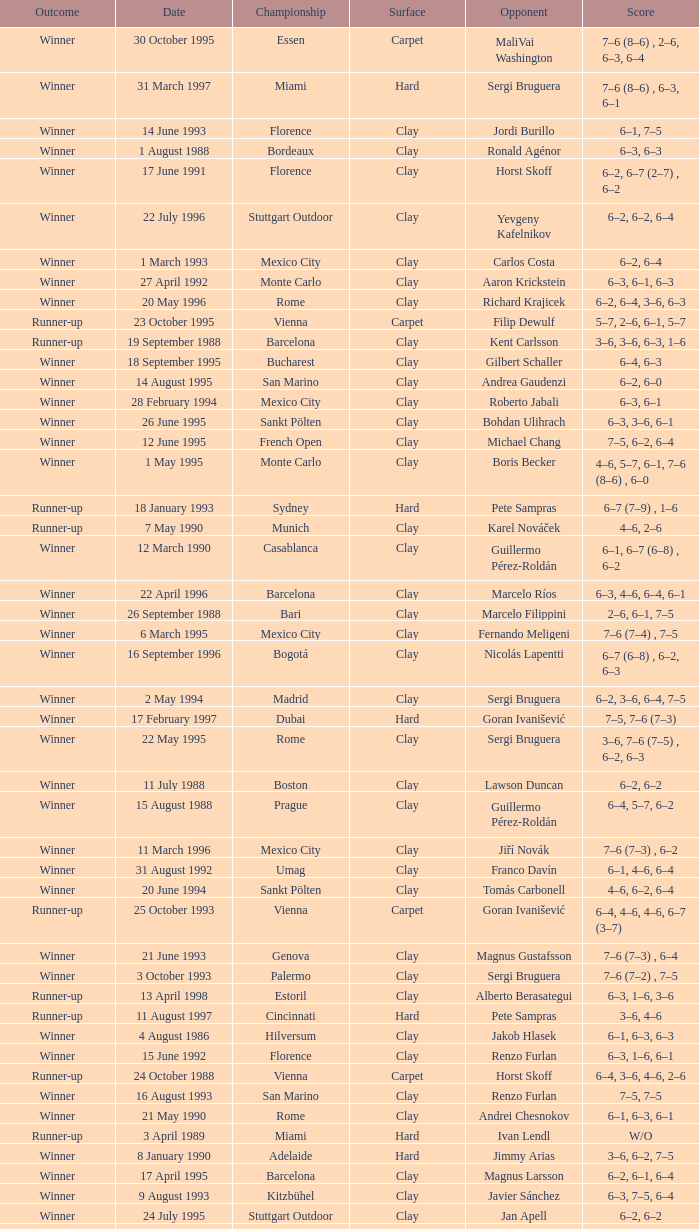Give me the full table as a dictionary. {'header': ['Outcome', 'Date', 'Championship', 'Surface', 'Opponent', 'Score'], 'rows': [['Winner', '30 October 1995', 'Essen', 'Carpet', 'MaliVai Washington', '7–6 (8–6) , 2–6, 6–3, 6–4'], ['Winner', '31 March 1997', 'Miami', 'Hard', 'Sergi Bruguera', '7–6 (8–6) , 6–3, 6–1'], ['Winner', '14 June 1993', 'Florence', 'Clay', 'Jordi Burillo', '6–1, 7–5'], ['Winner', '1 August 1988', 'Bordeaux', 'Clay', 'Ronald Agénor', '6–3, 6–3'], ['Winner', '17 June 1991', 'Florence', 'Clay', 'Horst Skoff', '6–2, 6–7 (2–7) , 6–2'], ['Winner', '22 July 1996', 'Stuttgart Outdoor', 'Clay', 'Yevgeny Kafelnikov', '6–2, 6–2, 6–4'], ['Winner', '1 March 1993', 'Mexico City', 'Clay', 'Carlos Costa', '6–2, 6–4'], ['Winner', '27 April 1992', 'Monte Carlo', 'Clay', 'Aaron Krickstein', '6–3, 6–1, 6–3'], ['Winner', '20 May 1996', 'Rome', 'Clay', 'Richard Krajicek', '6–2, 6–4, 3–6, 6–3'], ['Runner-up', '23 October 1995', 'Vienna', 'Carpet', 'Filip Dewulf', '5–7, 2–6, 6–1, 5–7'], ['Runner-up', '19 September 1988', 'Barcelona', 'Clay', 'Kent Carlsson', '3–6, 3–6, 6–3, 1–6'], ['Winner', '18 September 1995', 'Bucharest', 'Clay', 'Gilbert Schaller', '6–4, 6–3'], ['Winner', '14 August 1995', 'San Marino', 'Clay', 'Andrea Gaudenzi', '6–2, 6–0'], ['Winner', '28 February 1994', 'Mexico City', 'Clay', 'Roberto Jabali', '6–3, 6–1'], ['Winner', '26 June 1995', 'Sankt Pölten', 'Clay', 'Bohdan Ulihrach', '6–3, 3–6, 6–1'], ['Winner', '12 June 1995', 'French Open', 'Clay', 'Michael Chang', '7–5, 6–2, 6–4'], ['Winner', '1 May 1995', 'Monte Carlo', 'Clay', 'Boris Becker', '4–6, 5–7, 6–1, 7–6 (8–6) , 6–0'], ['Runner-up', '18 January 1993', 'Sydney', 'Hard', 'Pete Sampras', '6–7 (7–9) , 1–6'], ['Runner-up', '7 May 1990', 'Munich', 'Clay', 'Karel Nováček', '4–6, 2–6'], ['Winner', '12 March 1990', 'Casablanca', 'Clay', 'Guillermo Pérez-Roldán', '6–1, 6–7 (6–8) , 6–2'], ['Winner', '22 April 1996', 'Barcelona', 'Clay', 'Marcelo Ríos', '6–3, 4–6, 6–4, 6–1'], ['Winner', '26 September 1988', 'Bari', 'Clay', 'Marcelo Filippini', '2–6, 6–1, 7–5'], ['Winner', '6 March 1995', 'Mexico City', 'Clay', 'Fernando Meligeni', '7–6 (7–4) , 7–5'], ['Winner', '16 September 1996', 'Bogotá', 'Clay', 'Nicolás Lapentti', '6–7 (6–8) , 6–2, 6–3'], ['Winner', '2 May 1994', 'Madrid', 'Clay', 'Sergi Bruguera', '6–2, 3–6, 6–4, 7–5'], ['Winner', '17 February 1997', 'Dubai', 'Hard', 'Goran Ivanišević', '7–5, 7–6 (7–3)'], ['Winner', '22 May 1995', 'Rome', 'Clay', 'Sergi Bruguera', '3–6, 7–6 (7–5) , 6–2, 6–3'], ['Winner', '11 July 1988', 'Boston', 'Clay', 'Lawson Duncan', '6–2, 6–2'], ['Winner', '15 August 1988', 'Prague', 'Clay', 'Guillermo Pérez-Roldán', '6–4, 5–7, 6–2'], ['Winner', '11 March 1996', 'Mexico City', 'Clay', 'Jiří Novák', '7–6 (7–3) , 6–2'], ['Winner', '31 August 1992', 'Umag', 'Clay', 'Franco Davín', '6–1, 4–6, 6–4'], ['Winner', '20 June 1994', 'Sankt Pölten', 'Clay', 'Tomás Carbonell', '4–6, 6–2, 6–4'], ['Runner-up', '25 October 1993', 'Vienna', 'Carpet', 'Goran Ivanišević', '6–4, 4–6, 4–6, 6–7 (3–7)'], ['Winner', '21 June 1993', 'Genova', 'Clay', 'Magnus Gustafsson', '7–6 (7–3) , 6–4'], ['Winner', '3 October 1993', 'Palermo', 'Clay', 'Sergi Bruguera', '7–6 (7–2) , 7–5'], ['Runner-up', '13 April 1998', 'Estoril', 'Clay', 'Alberto Berasategui', '6–3, 1–6, 3–6'], ['Runner-up', '11 August 1997', 'Cincinnati', 'Hard', 'Pete Sampras', '3–6, 4–6'], ['Winner', '4 August 1986', 'Hilversum', 'Clay', 'Jakob Hlasek', '6–1, 6–3, 6–3'], ['Winner', '15 June 1992', 'Florence', 'Clay', 'Renzo Furlan', '6–3, 1–6, 6–1'], ['Runner-up', '24 October 1988', 'Vienna', 'Carpet', 'Horst Skoff', '6–4, 3–6, 4–6, 2–6'], ['Winner', '16 August 1993', 'San Marino', 'Clay', 'Renzo Furlan', '7–5, 7–5'], ['Winner', '21 May 1990', 'Rome', 'Clay', 'Andrei Chesnokov', '6–1, 6–3, 6–1'], ['Runner-up', '3 April 1989', 'Miami', 'Hard', 'Ivan Lendl', 'W/O'], ['Winner', '8 January 1990', 'Adelaide', 'Hard', 'Jimmy Arias', '3–6, 6–2, 7–5'], ['Winner', '17 April 1995', 'Barcelona', 'Clay', 'Magnus Larsson', '6–2, 6–1, 6–4'], ['Winner', '9 August 1993', 'Kitzbühel', 'Clay', 'Javier Sánchez', '6–3, 7–5, 6–4'], ['Winner', '24 July 1995', 'Stuttgart Outdoor', 'Clay', 'Jan Apell', '6–2, 6–2'], ['Runner-up', '7 August 1995', 'Kitzbühel', 'Clay', 'Albert Costa', '6–4, 4–6, 6–7 (3–7) , 6–2, 4–6'], ['Runner-up', '30 April 1990', 'Monte Carlo', 'Clay', 'Andrei Chesnokov', '5–7, 3–6, 3–6'], ['Winner', '30 August 1993', 'Umag', 'Clay', 'Alberto Berasategui', '7–5, 3–6, 6–3'], ['Winner', '16 September 1991', 'Geneva', 'Clay', 'Horst Skoff', '6–2, 6–4'], ['Winner', '15 April 1996', 'Estoril', 'Clay', 'Andrea Gaudenzi', '7–6 (7–4) , 6–4'], ['Winner', '28 August 1995', 'Umag', 'Clay', 'Carlos Costa', '3–6, 7–6 (7–5) , 6–4'], ['Winner', '10 April 1995', 'Estoril', 'Clay', 'Albert Costa', '6–4, 6–2'], ['Winner', '29 April 1996', 'Monte Carlo', 'Clay', 'Albert Costa', '6–3, 5–7, 4–6, 6–3, 6–2']]} What is the score when the outcome is winner against yevgeny kafelnikov? 6–2, 6–2, 6–4. 